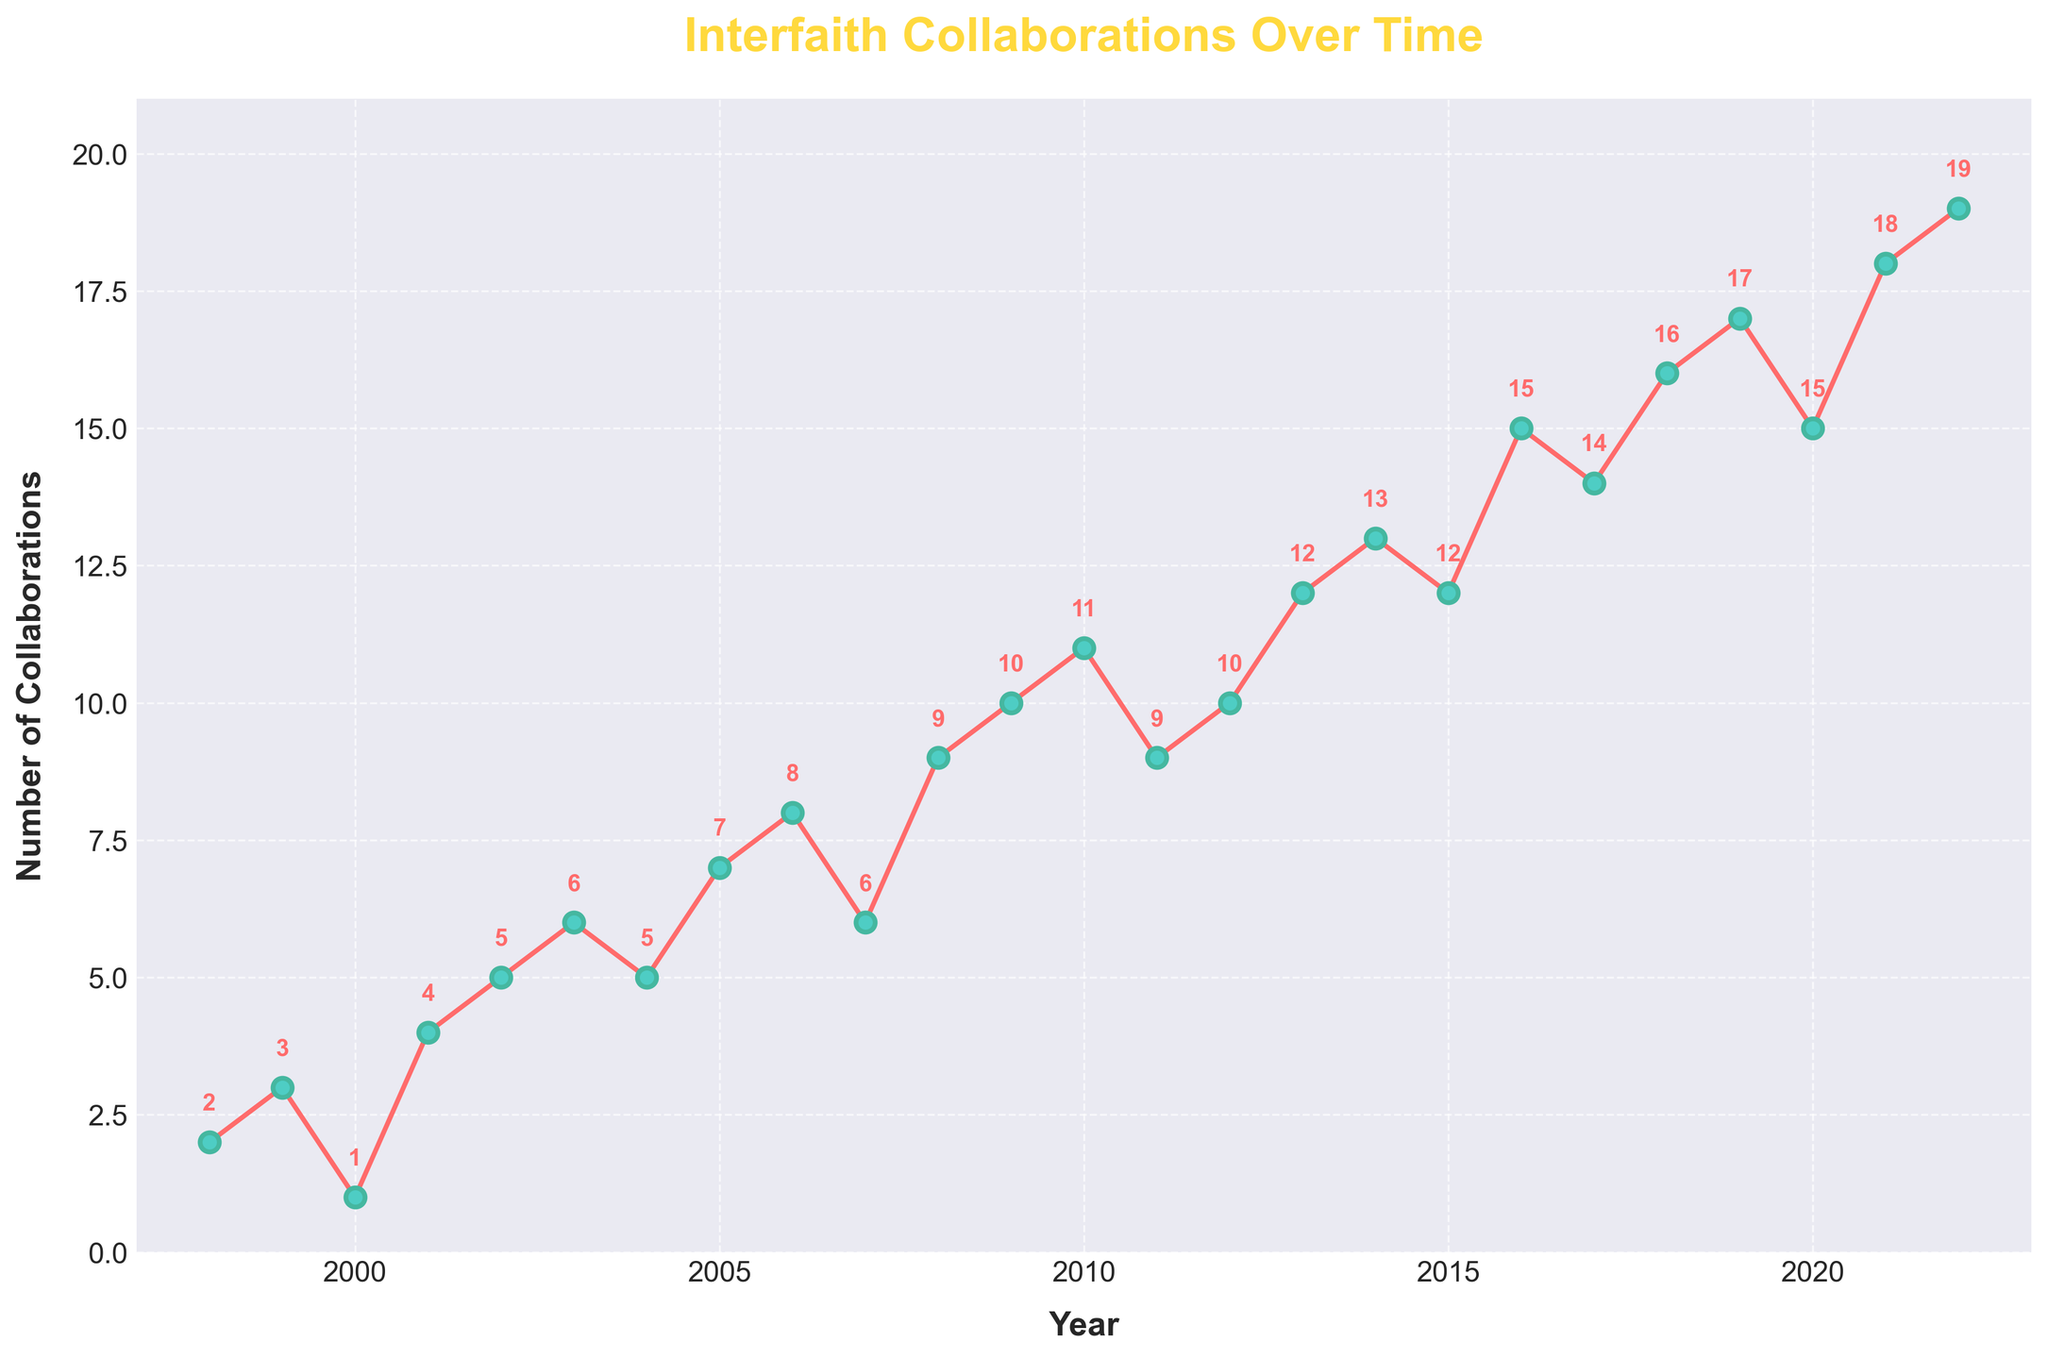What is the title of the figure? The title is usually located at the top of the figure and is meant to give a quick idea of what the plot is about. In this figure, it states "Interfaith Collaborations Over Time."
Answer: Interfaith Collaborations Over Time What does the x-axis represent? The x-axis at the bottom of the figure usually represents the time intervals, and in this figure, it indicates the 'Year' from 1998 to 2022.
Answer: Year What does the y-axis represent? The y-axis on the left side of the figure represents the count of something being measured, and in this case, it represents the 'Number of Collaborations'.
Answer: Number of Collaborations How many collaborations were recorded in the year 2003? To find the number of collaborations in a specific year, locate the year on the x-axis and follow it upwards to the data point, then read the value on the y-axis. For 2003, the number corresponds to 6.
Answer: 6 What was the trend in the number of collaborations between 2008 and 2010? To determine the trend, look at the data points between the specified years and the direction in which they are moving. From 2008 to 2010, the number of collaborations increased from 9 to 11.
Answer: Increasing What is the average number of collaborations per year over the 25 years? To calculate the average, sum all the yearly collaboration counts and divide by the number of years (25). The sum is 246, so the average is 246 / 25 = 9.84.
Answer: 9.84 In which year did the number of collaborations peak? Identifying the peak involves finding the highest point on the plot. The highest value is 19, which occurs in the year 2022.
Answer: 2022 Which year had fewer collaborations, 1999 or 2000? Compare the number of collaborations for each year by locating the values on the plot. 1999 had 3 collaborations, while 2000 had 1.
Answer: 2000 How many times did the number of collaborations decrease from one year to the next? Count the number of downward transitions between consecutive years. There were decreases in 2000, 2007, 2011, 2015, 2017, and 2020, so a total of 6 times.
Answer: 6 What's the difference in collaborations between the years with the highest and the lowest counts? Find the values for the peak (19 in 2022) and the lowest (1 in 2000) and compute the difference. 19 - 1 = 18.
Answer: 18 